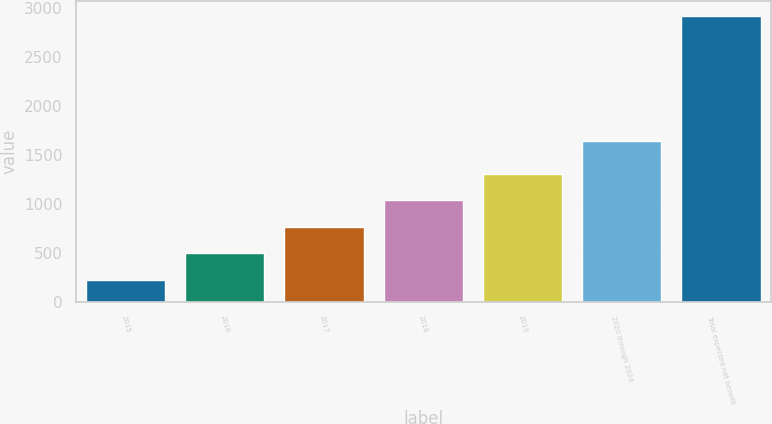Convert chart. <chart><loc_0><loc_0><loc_500><loc_500><bar_chart><fcel>2015<fcel>2016<fcel>2017<fcel>2018<fcel>2019<fcel>2020 through 2024<fcel>Total expected net benefit<nl><fcel>229<fcel>498.8<fcel>768.6<fcel>1038.4<fcel>1308.2<fcel>1643<fcel>2927<nl></chart> 